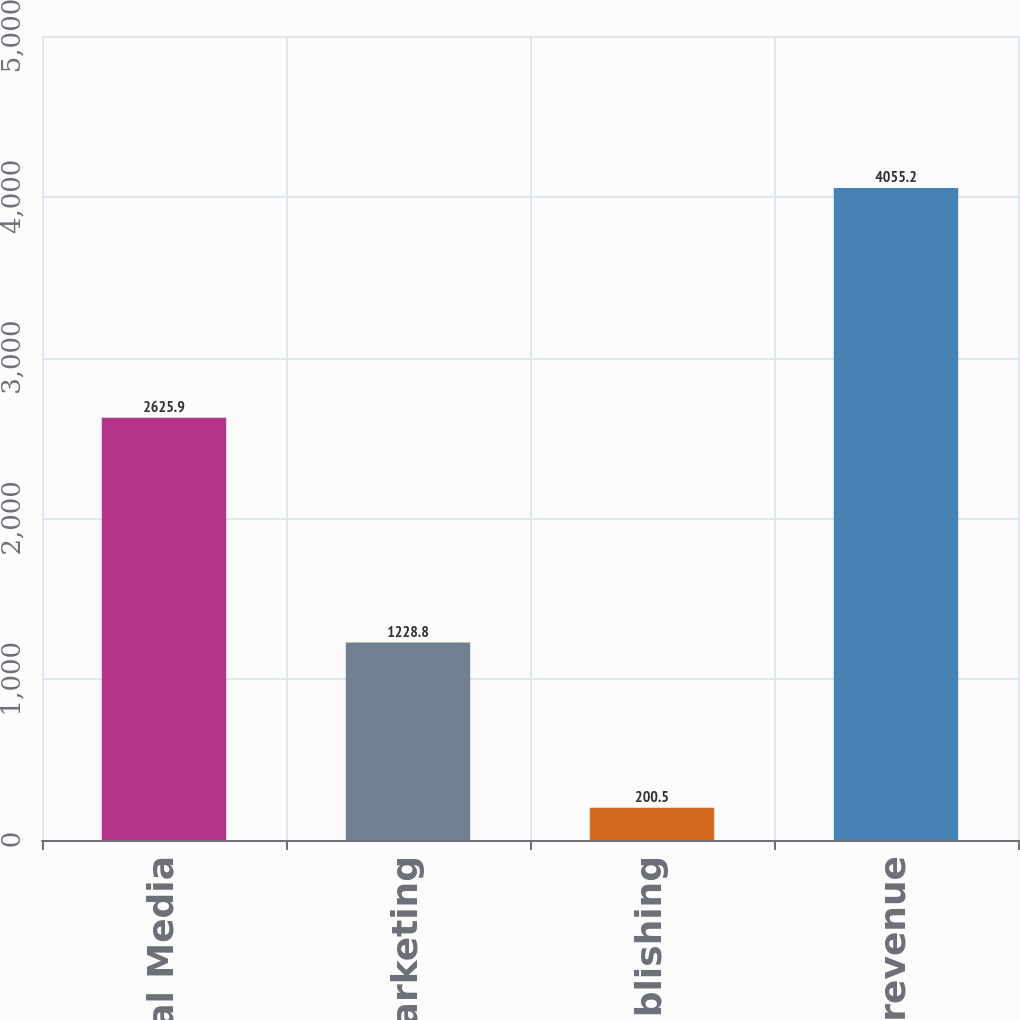Convert chart. <chart><loc_0><loc_0><loc_500><loc_500><bar_chart><fcel>Digital Media<fcel>Digital Marketing<fcel>Print and Publishing<fcel>Total revenue<nl><fcel>2625.9<fcel>1228.8<fcel>200.5<fcel>4055.2<nl></chart> 